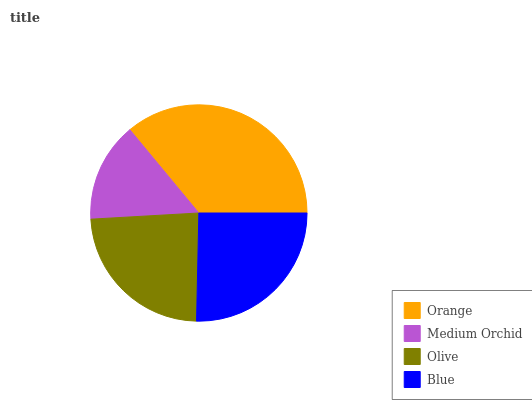Is Medium Orchid the minimum?
Answer yes or no. Yes. Is Orange the maximum?
Answer yes or no. Yes. Is Olive the minimum?
Answer yes or no. No. Is Olive the maximum?
Answer yes or no. No. Is Olive greater than Medium Orchid?
Answer yes or no. Yes. Is Medium Orchid less than Olive?
Answer yes or no. Yes. Is Medium Orchid greater than Olive?
Answer yes or no. No. Is Olive less than Medium Orchid?
Answer yes or no. No. Is Blue the high median?
Answer yes or no. Yes. Is Olive the low median?
Answer yes or no. Yes. Is Olive the high median?
Answer yes or no. No. Is Blue the low median?
Answer yes or no. No. 